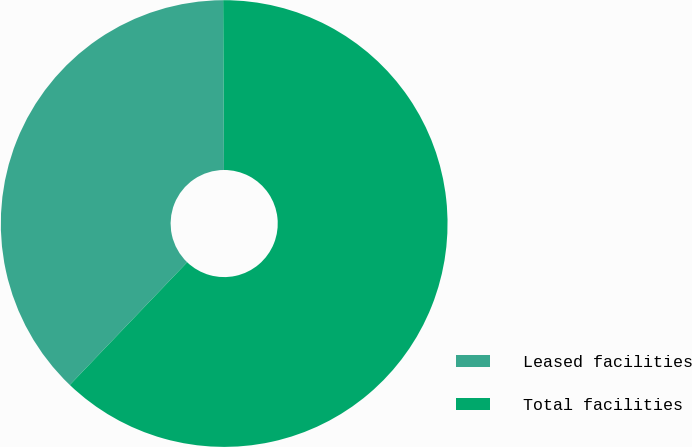Convert chart. <chart><loc_0><loc_0><loc_500><loc_500><pie_chart><fcel>Leased facilities<fcel>Total facilities<nl><fcel>37.78%<fcel>62.22%<nl></chart> 